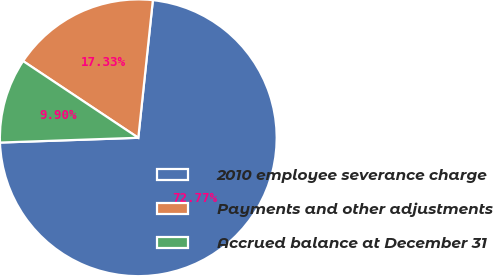<chart> <loc_0><loc_0><loc_500><loc_500><pie_chart><fcel>2010 employee severance charge<fcel>Payments and other adjustments<fcel>Accrued balance at December 31<nl><fcel>72.77%<fcel>17.33%<fcel>9.9%<nl></chart> 